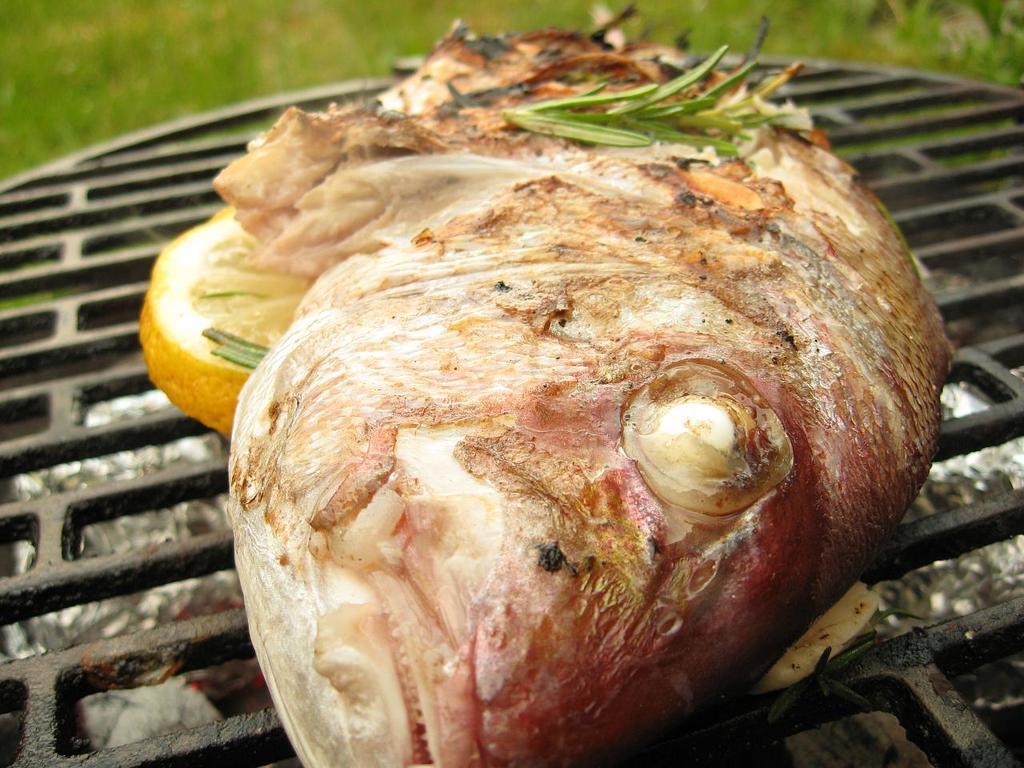What is being cooked on the grill in the image? There is food on the grill in the image. What colors can be seen on the food? The food has colors including cream, yellow, green, and red. What can be seen in the background of the image? There are plants visible in the background of the image. What type of grain is being used to support the theory in the image? There is no mention of grain or a theory in the image; it features food on a grill with plants in the background. 